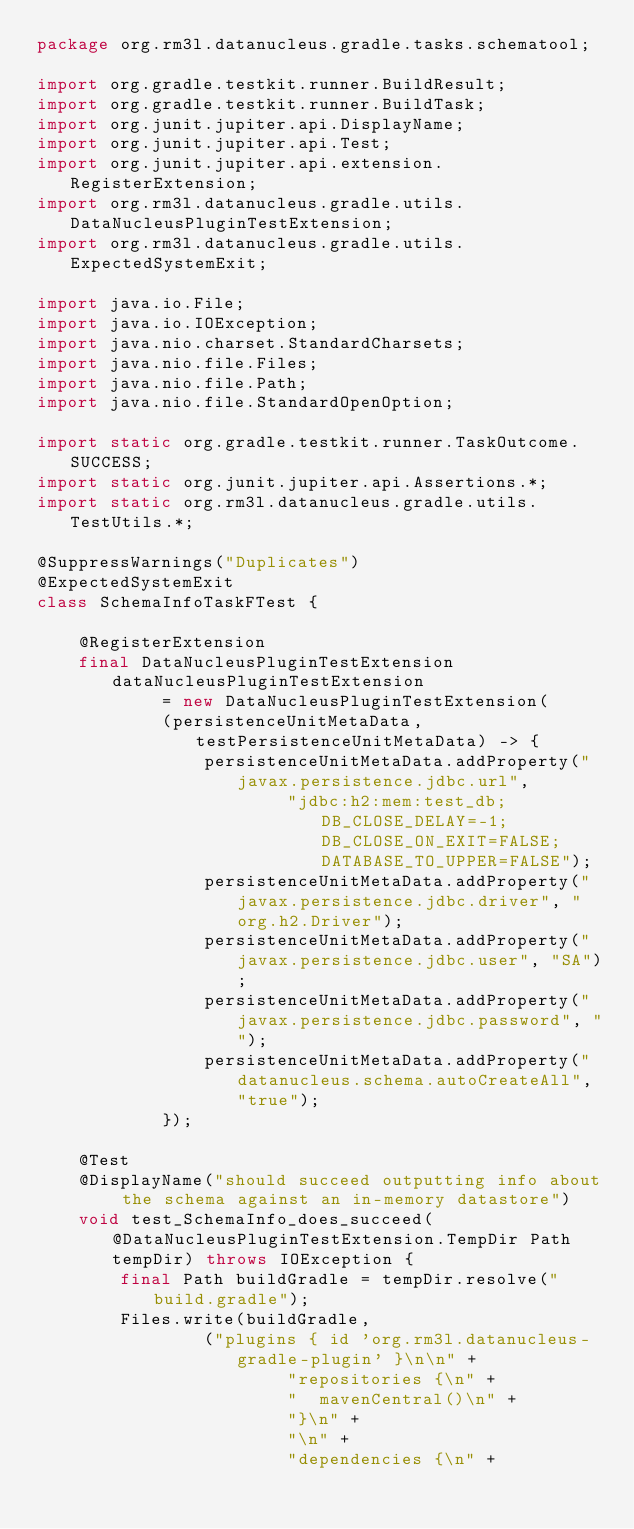Convert code to text. <code><loc_0><loc_0><loc_500><loc_500><_Java_>package org.rm3l.datanucleus.gradle.tasks.schematool;

import org.gradle.testkit.runner.BuildResult;
import org.gradle.testkit.runner.BuildTask;
import org.junit.jupiter.api.DisplayName;
import org.junit.jupiter.api.Test;
import org.junit.jupiter.api.extension.RegisterExtension;
import org.rm3l.datanucleus.gradle.utils.DataNucleusPluginTestExtension;
import org.rm3l.datanucleus.gradle.utils.ExpectedSystemExit;

import java.io.File;
import java.io.IOException;
import java.nio.charset.StandardCharsets;
import java.nio.file.Files;
import java.nio.file.Path;
import java.nio.file.StandardOpenOption;

import static org.gradle.testkit.runner.TaskOutcome.SUCCESS;
import static org.junit.jupiter.api.Assertions.*;
import static org.rm3l.datanucleus.gradle.utils.TestUtils.*;

@SuppressWarnings("Duplicates")
@ExpectedSystemExit
class SchemaInfoTaskFTest {

    @RegisterExtension
    final DataNucleusPluginTestExtension dataNucleusPluginTestExtension
            = new DataNucleusPluginTestExtension(
            (persistenceUnitMetaData, testPersistenceUnitMetaData) -> {
                persistenceUnitMetaData.addProperty("javax.persistence.jdbc.url",
                        "jdbc:h2:mem:test_db;DB_CLOSE_DELAY=-1;DB_CLOSE_ON_EXIT=FALSE;DATABASE_TO_UPPER=FALSE");
                persistenceUnitMetaData.addProperty("javax.persistence.jdbc.driver", "org.h2.Driver");
                persistenceUnitMetaData.addProperty("javax.persistence.jdbc.user", "SA");
                persistenceUnitMetaData.addProperty("javax.persistence.jdbc.password", "");
                persistenceUnitMetaData.addProperty("datanucleus.schema.autoCreateAll", "true");
            });

    @Test
    @DisplayName("should succeed outputting info about the schema against an in-memory datastore")
    void test_SchemaInfo_does_succeed(@DataNucleusPluginTestExtension.TempDir Path tempDir) throws IOException {
        final Path buildGradle = tempDir.resolve("build.gradle");
        Files.write(buildGradle,
                ("plugins { id 'org.rm3l.datanucleus-gradle-plugin' }\n\n" +
                        "repositories {\n" +
                        "  mavenCentral()\n" +
                        "}\n" +
                        "\n" +
                        "dependencies {\n" +</code> 